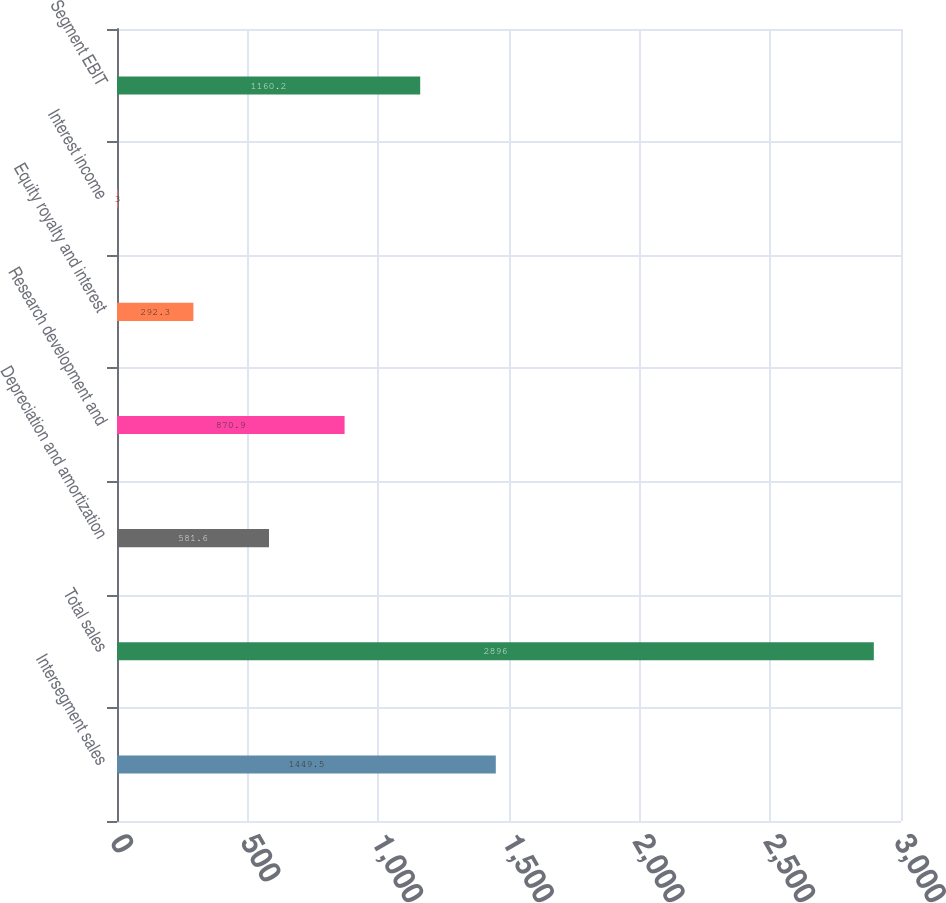Convert chart. <chart><loc_0><loc_0><loc_500><loc_500><bar_chart><fcel>Intersegment sales<fcel>Total sales<fcel>Depreciation and amortization<fcel>Research development and<fcel>Equity royalty and interest<fcel>Interest income<fcel>Segment EBIT<nl><fcel>1449.5<fcel>2896<fcel>581.6<fcel>870.9<fcel>292.3<fcel>3<fcel>1160.2<nl></chart> 